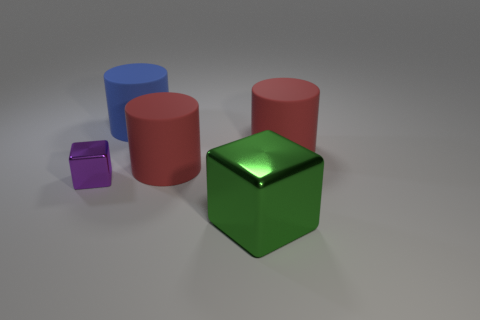Add 5 tiny cyan rubber blocks. How many objects exist? 10 Subtract all cylinders. How many objects are left? 2 Subtract 1 purple blocks. How many objects are left? 4 Subtract all purple balls. Subtract all blue rubber cylinders. How many objects are left? 4 Add 5 purple objects. How many purple objects are left? 6 Add 2 large shiny cubes. How many large shiny cubes exist? 3 